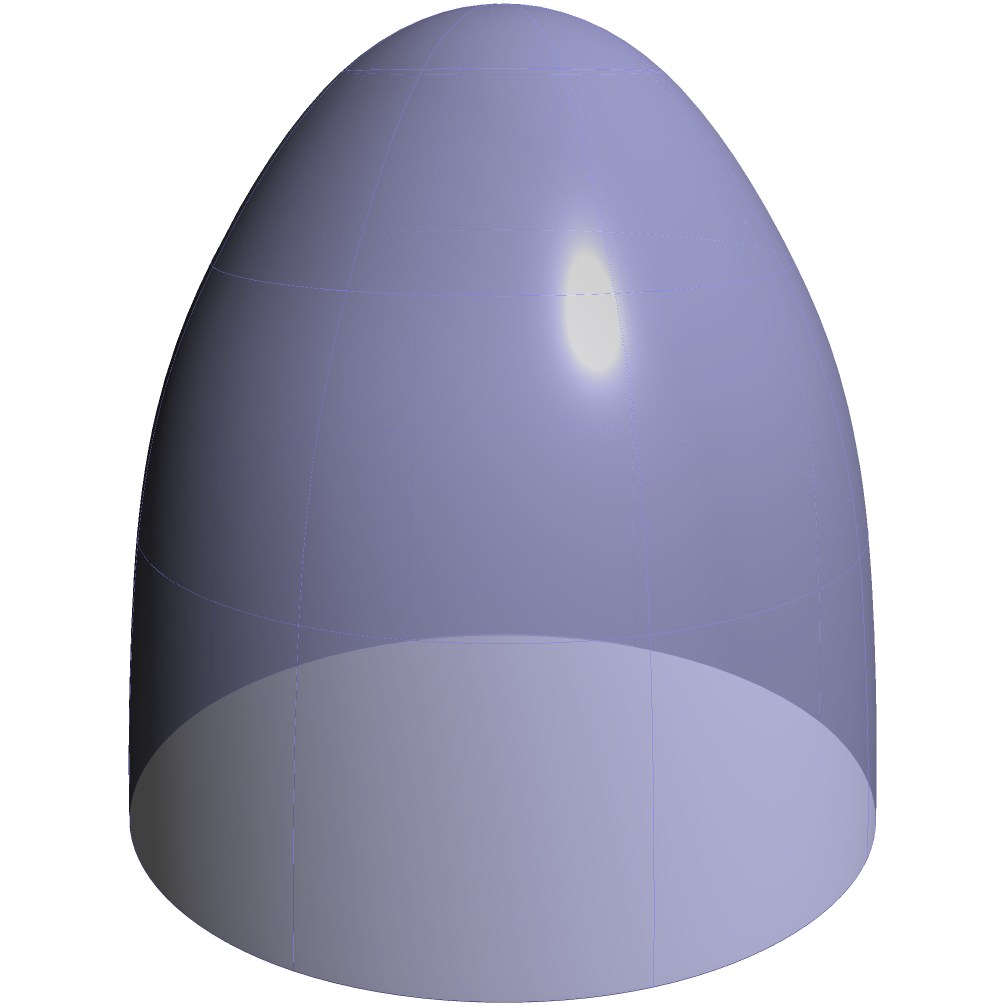On a spherical Earth representing life's journey, point A (1,0,0) symbolizes a child's starting point, and point B (0,1,0) represents their future goal. If the shortest path between these points represents the optimal route for personal growth, what is the length of this path? How might this concept relate to guiding children towards a positive self-image? To solve this problem and relate it to child development, let's follow these steps:

1) In spherical geometry, the shortest path between two points is along a great circle, which is represented by the red arc in the diagram.

2) To find the length of this arc, we need to calculate the central angle between points A and B, then multiply it by the radius of the sphere (which is 1 in this case).

3) The central angle θ can be found using the dot product formula:
   $$\cos(\theta) = \frac{A \cdot B}{|A||B|}$$

4) Given A = (1,0,0) and B = (0,1,0):
   $$\cos(\theta) = \frac{(1)(0) + (0)(1) + (0)(0)}{1} = 0$$

5) Therefore, $$\theta = \arccos(0) = \frac{\pi}{2}$$ radians or 90°

6) The length of the arc is:
   $$l = r\theta = (1)(\frac{\pi}{2}) = \frac{\pi}{2}$$

7) Relating this to child development and self-esteem:
   - The shortest path (π/2) represents the ideal journey of self-discovery and growth.
   - However, life's journey is rarely a straight line, much like a child's path to self-confidence.
   - As a pediatrician, we can guide children along this "optimal path" by:
     a) Encouraging exploration of their strengths (moving along the sphere)
     b) Providing support when they deviate from the path (returning to the great circle)
     c) Emphasizing that the journey (the entire sphere) is as important as the destination (point B)
   - This approach fosters resilience and a positive self-image, as children learn to navigate their unique path while maintaining sight of their goals.
Answer: $\frac{\pi}{2}$ 